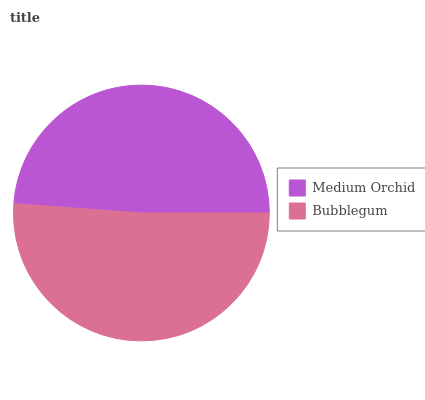Is Medium Orchid the minimum?
Answer yes or no. Yes. Is Bubblegum the maximum?
Answer yes or no. Yes. Is Bubblegum the minimum?
Answer yes or no. No. Is Bubblegum greater than Medium Orchid?
Answer yes or no. Yes. Is Medium Orchid less than Bubblegum?
Answer yes or no. Yes. Is Medium Orchid greater than Bubblegum?
Answer yes or no. No. Is Bubblegum less than Medium Orchid?
Answer yes or no. No. Is Bubblegum the high median?
Answer yes or no. Yes. Is Medium Orchid the low median?
Answer yes or no. Yes. Is Medium Orchid the high median?
Answer yes or no. No. Is Bubblegum the low median?
Answer yes or no. No. 